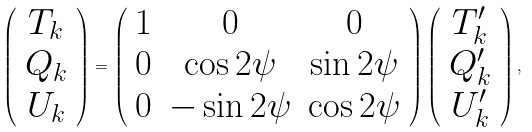Convert formula to latex. <formula><loc_0><loc_0><loc_500><loc_500>\left ( \begin{array} { c } T _ { k } \\ Q _ { k } \\ U _ { k } \end{array} \right ) = \left ( \begin{array} { c c c } 1 & 0 & 0 \\ 0 & \cos 2 \psi & \sin 2 \psi \\ 0 & - \sin 2 \psi & \cos 2 \psi \end{array} \right ) \left ( \begin{array} { c } T ^ { \prime } _ { k } \\ Q ^ { \prime } _ { k } \\ U ^ { \prime } _ { k } \end{array} \right ) ,</formula> 